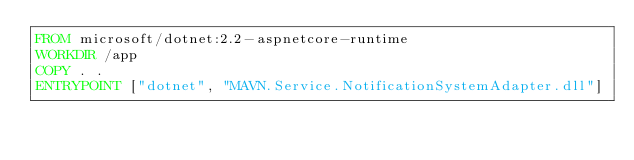Convert code to text. <code><loc_0><loc_0><loc_500><loc_500><_Dockerfile_>FROM microsoft/dotnet:2.2-aspnetcore-runtime
WORKDIR /app
COPY . .
ENTRYPOINT ["dotnet", "MAVN.Service.NotificationSystemAdapter.dll"]
</code> 